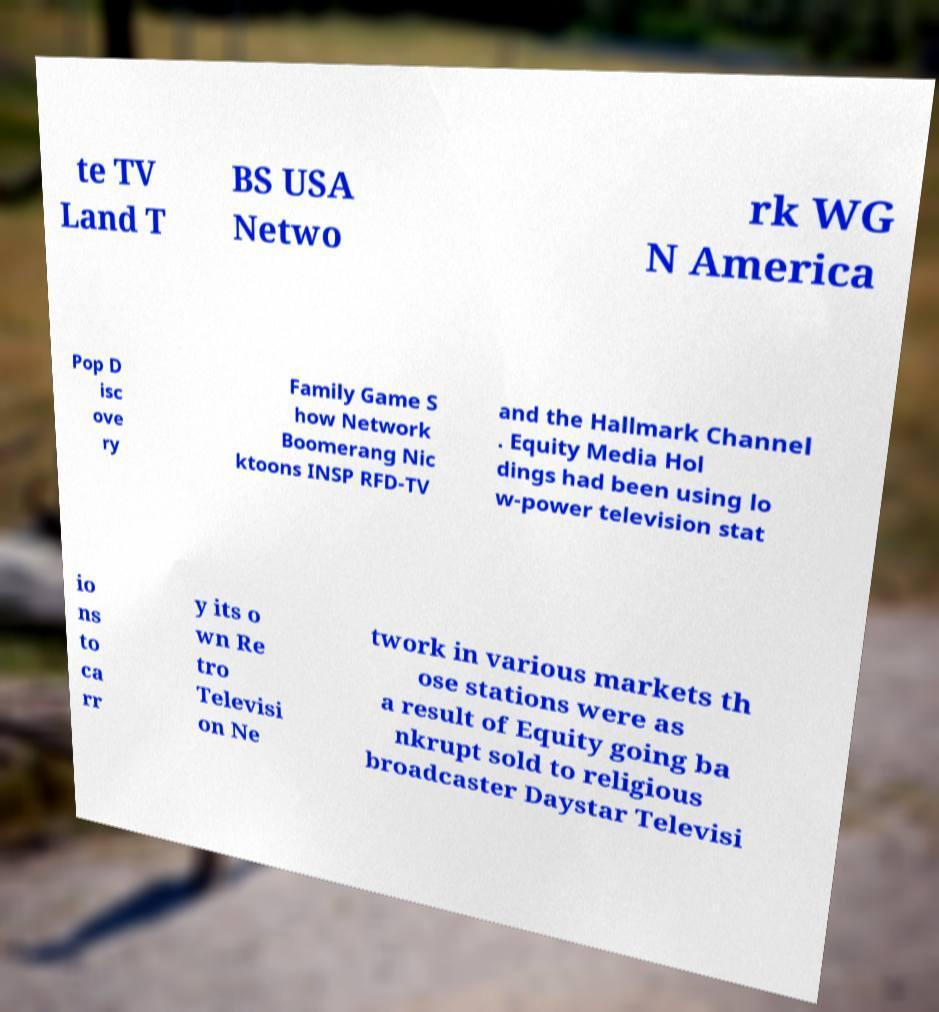Can you accurately transcribe the text from the provided image for me? te TV Land T BS USA Netwo rk WG N America Pop D isc ove ry Family Game S how Network Boomerang Nic ktoons INSP RFD-TV and the Hallmark Channel . Equity Media Hol dings had been using lo w-power television stat io ns to ca rr y its o wn Re tro Televisi on Ne twork in various markets th ose stations were as a result of Equity going ba nkrupt sold to religious broadcaster Daystar Televisi 